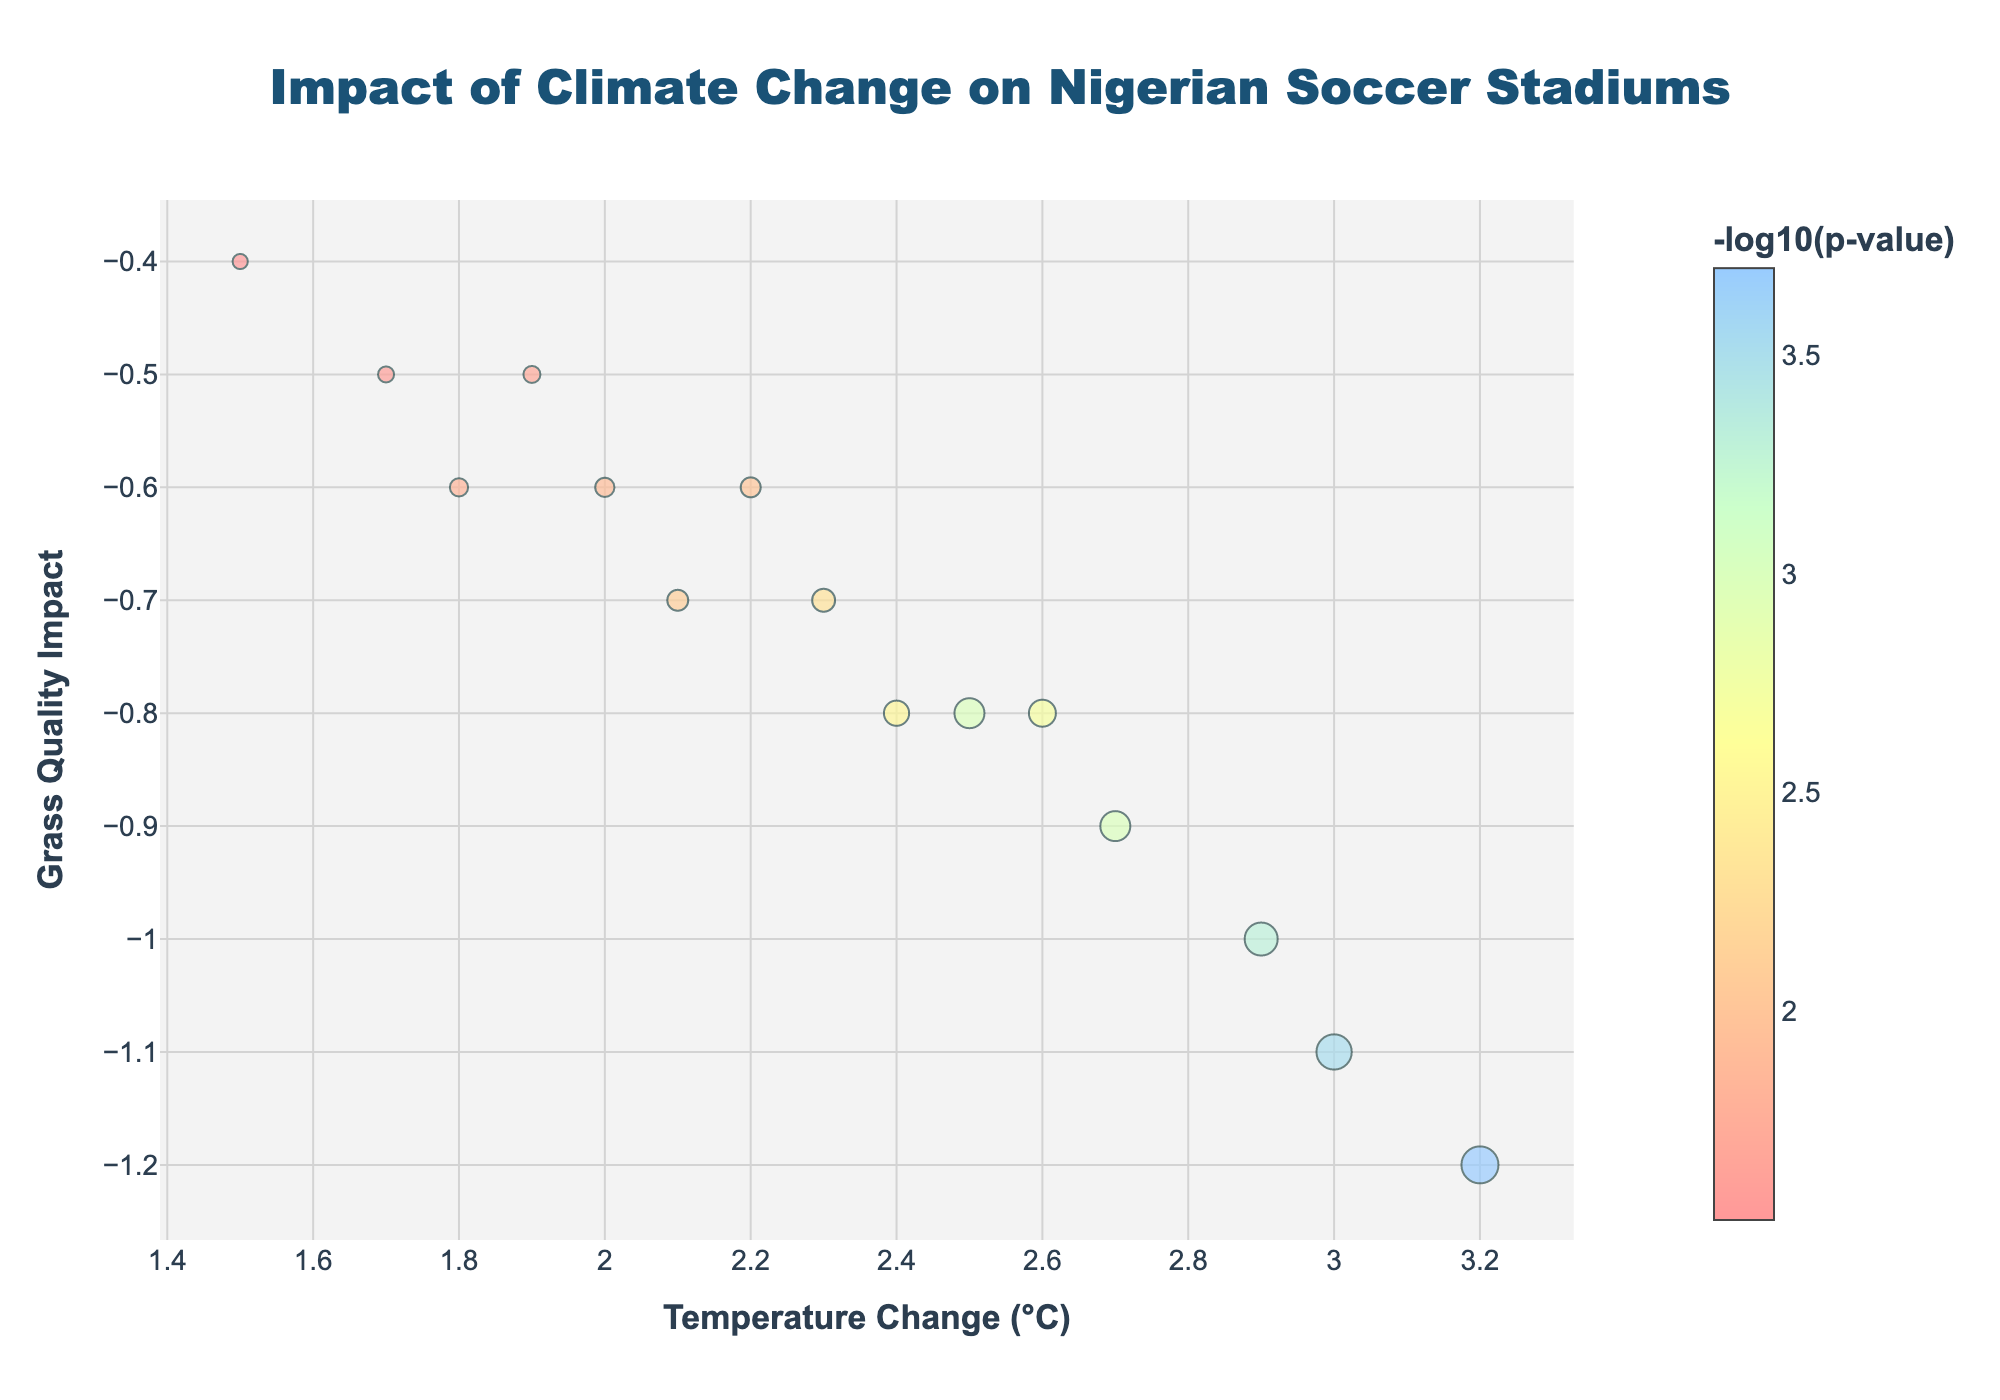What is the stadium with the highest temperature change? Identify the data point with the highest x-axis value. "Sani Abacha Stadium" has the highest temperature change of 3.2°C.
Answer: Sani Abacha Stadium What does the color scale represent? Look at the color bar on the side of the plot. It indicates -log10(p-value).
Answer: -log10(p-value) Which stadium shows the most significant impact on grass quality? The most significant impact corresponds to the lowest grass quality impact (y-axis) value along with the highest -log10(p-value). "Sani Abacha Stadium" has the lowest grass quality impact of -1.2.
Answer: Sani Abacha Stadium What is the title of the plot? The plot's title is clearly written at the top. It reads "Impact of Climate Change on Nigerian Soccer Stadiums."
Answer: Impact of Climate Change on Nigerian Soccer Stadiums How many data points (stadiums) are shown in the figure? Count the number of markers depicted in the plot. There are 15 markers.
Answer: 15 Which stadium reported a temperature change of approximately 2.1°C and what is the grass quality impact for this stadium? Identify the stadium with a temperature change around 2.1°C and then check its y-axis value. "Adokiye Amiesimaka Stadium" has a temperature change of 2.1°C and a grass quality impact of -0.7.
Answer: Adokiye Amiesimaka Stadium, -0.7 How does the grass quality impact vary with increasing temperature change? Analyze the trend of y-axis values as x-axis values increase. The grass quality generally decreases (more negative impact) with increasing temperature change.
Answer: Grass quality decreases Which stadiums have temperature changes greater than 2.5°C? Identify data points right of the x-axis value of 2.5. "Teslim Balogun Stadium," "Sani Abacha Stadium," "Ahmadu Bello Stadium," "Abubakar Tafawa Balewa Stadium," "Moshood Abiola National Stadium," and "Yakubu Gowon Stadium" all have temperature changes greater than 2.5°C.
Answer: Teslim Balogun, Sani Abacha, Ahmadu Bello, Abubakar Tafawa Balewa, Moshood Abiola, Yakubu Gowon Which two stadiums have similar impacts on grass quality but differ in temperature change? Look for two data points with almost the same y-axis values but different x-axis values. "Nnamdi Azikiwe Stadium" and "Adokiye Amiesimaka Stadium" both have a grass quality impact of -0.7 but temperature changes of 2.3°C and 2.1°C respectively.
Answer: Nnamdi Azikiwe Stadium and Adokiye Amiesimaka Stadium 